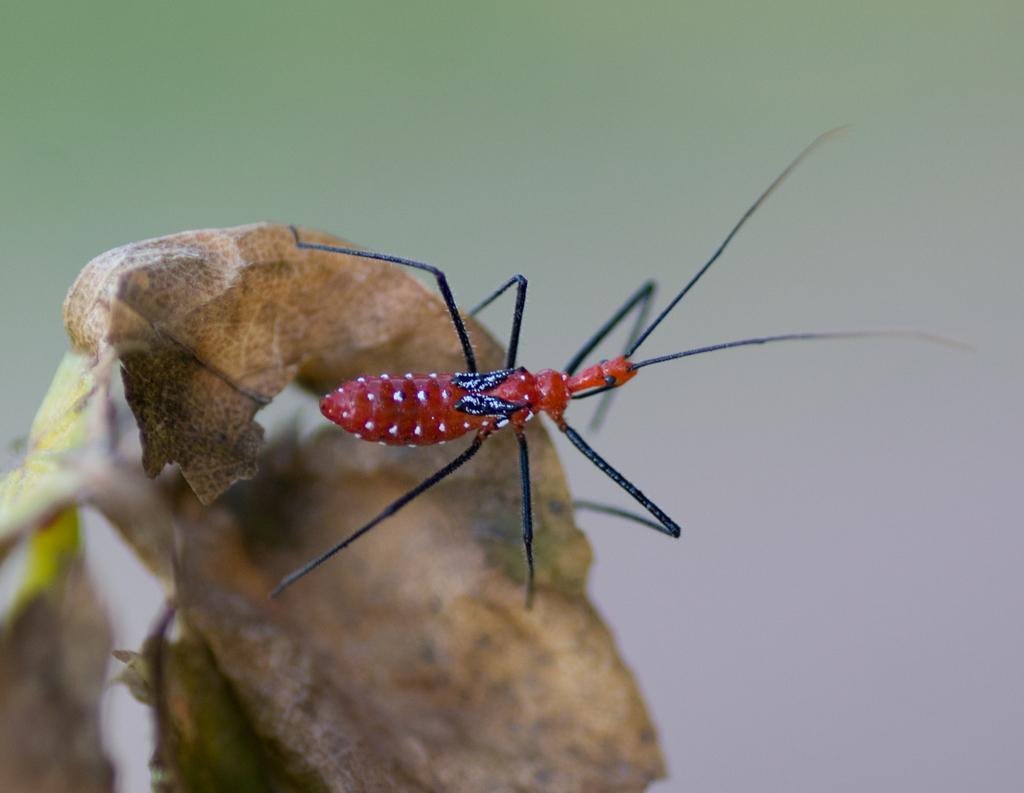What is the main subject of the image? There is an insect in the image. Where is the insect located? The insect is on a dry leaf. Can you describe the background of the image? The background of the image is blurry. How many steps can be seen in the garden in the image? There is no garden or steps present in the image; it features an insect on a dry leaf with a blurry background. 